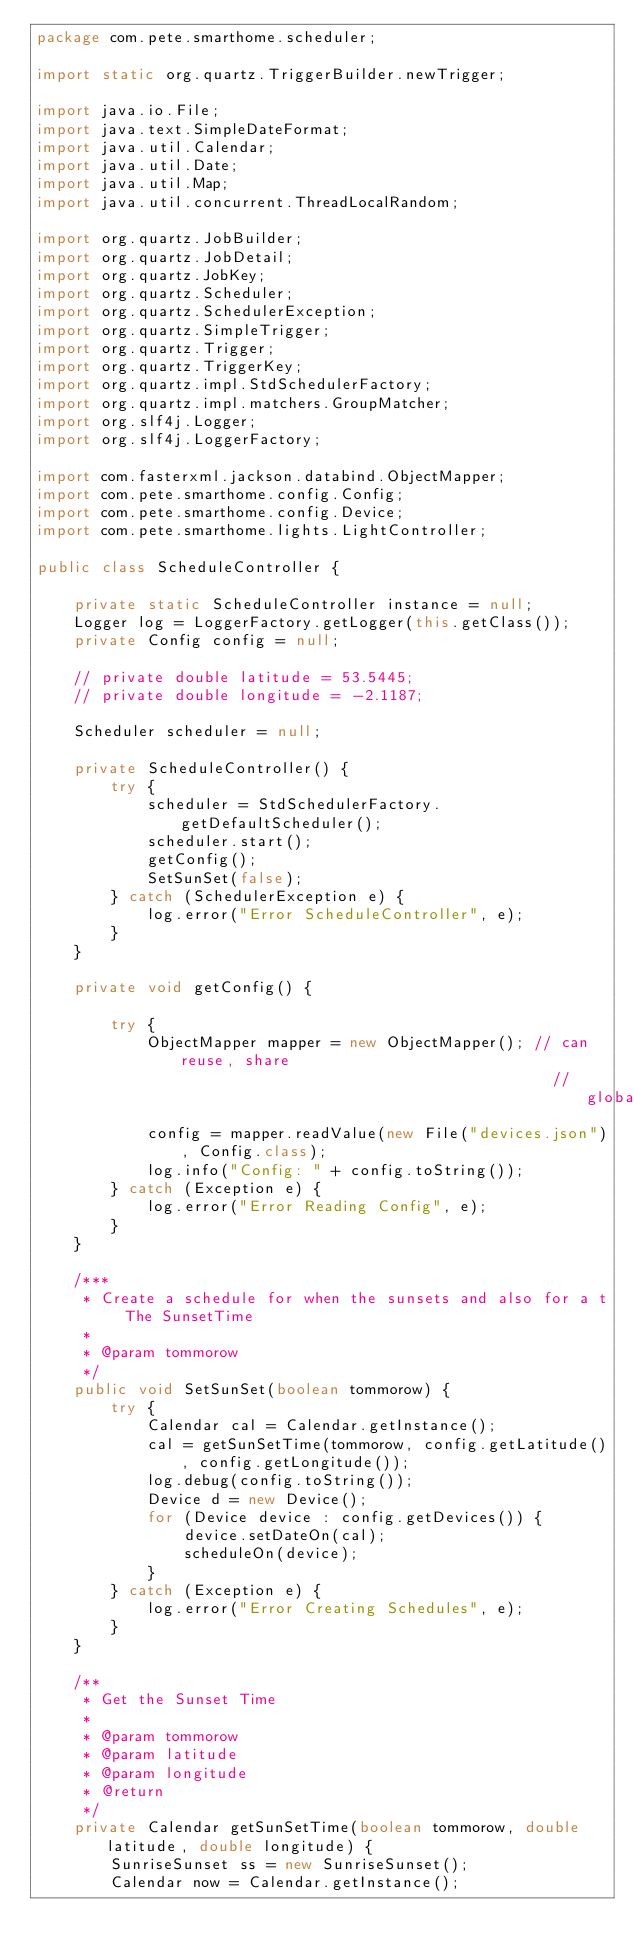<code> <loc_0><loc_0><loc_500><loc_500><_Java_>package com.pete.smarthome.scheduler;

import static org.quartz.TriggerBuilder.newTrigger;

import java.io.File;
import java.text.SimpleDateFormat;
import java.util.Calendar;
import java.util.Date;
import java.util.Map;
import java.util.concurrent.ThreadLocalRandom;

import org.quartz.JobBuilder;
import org.quartz.JobDetail;
import org.quartz.JobKey;
import org.quartz.Scheduler;
import org.quartz.SchedulerException;
import org.quartz.SimpleTrigger;
import org.quartz.Trigger;
import org.quartz.TriggerKey;
import org.quartz.impl.StdSchedulerFactory;
import org.quartz.impl.matchers.GroupMatcher;
import org.slf4j.Logger;
import org.slf4j.LoggerFactory;

import com.fasterxml.jackson.databind.ObjectMapper;
import com.pete.smarthome.config.Config;
import com.pete.smarthome.config.Device;
import com.pete.smarthome.lights.LightController;

public class ScheduleController {

	private static ScheduleController instance = null;
	Logger log = LoggerFactory.getLogger(this.getClass());
	private Config config = null;

	// private double latitude = 53.5445;
	// private double longitude = -2.1187;

	Scheduler scheduler = null;

	private ScheduleController() {
		try {
			scheduler = StdSchedulerFactory.getDefaultScheduler();
			scheduler.start();
			getConfig();
			SetSunSet(false);
		} catch (SchedulerException e) {
			log.error("Error ScheduleController", e);
		}
	}

	private void getConfig() {

		try {
			ObjectMapper mapper = new ObjectMapper(); // can reuse, share
														// globally
			config = mapper.readValue(new File("devices.json"), Config.class);
			log.info("Config: " + config.toString());
		} catch (Exception e) {
			log.error("Error Reading Config", e);
		}
	}

	/***
	 * Create a schedule for when the sunsets and also for a t The SunsetTime
	 * 
	 * @param tommorow
	 */
	public void SetSunSet(boolean tommorow) {
		try {
			Calendar cal = Calendar.getInstance();
			cal = getSunSetTime(tommorow, config.getLatitude(), config.getLongitude());
			log.debug(config.toString());
			Device d = new Device();
			for (Device device : config.getDevices()) {
				device.setDateOn(cal);
				scheduleOn(device);
			}
		} catch (Exception e) {
			log.error("Error Creating Schedules", e);
		}
	}

	/**
	 * Get the Sunset Time
	 * 
	 * @param tommorow
	 * @param latitude
	 * @param longitude
	 * @return
	 */
	private Calendar getSunSetTime(boolean tommorow, double latitude, double longitude) {
		SunriseSunset ss = new SunriseSunset();
		Calendar now = Calendar.getInstance();</code> 